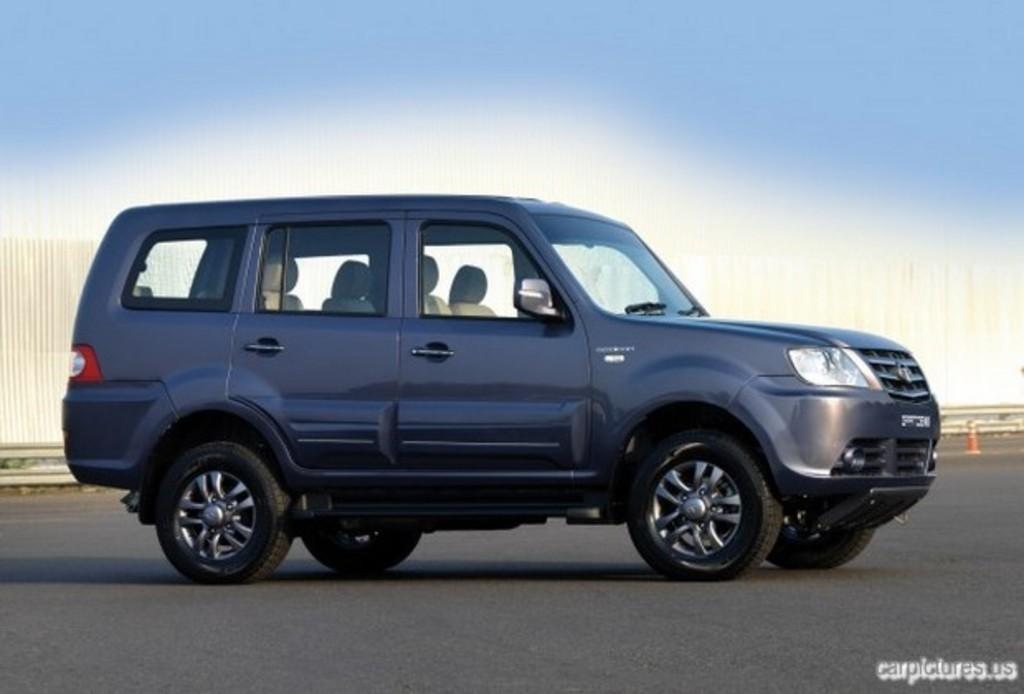What is the main subject of the image? There is a vehicle in the image. Where is the vehicle located? The vehicle is parked on the road. Is there any text visible in the image? Yes, there is some text at the bottom right corner of the image. Can you see a dog saying good-bye with a kiss in the image? No, there is no dog or any indication of a good-bye or kiss in the image. 